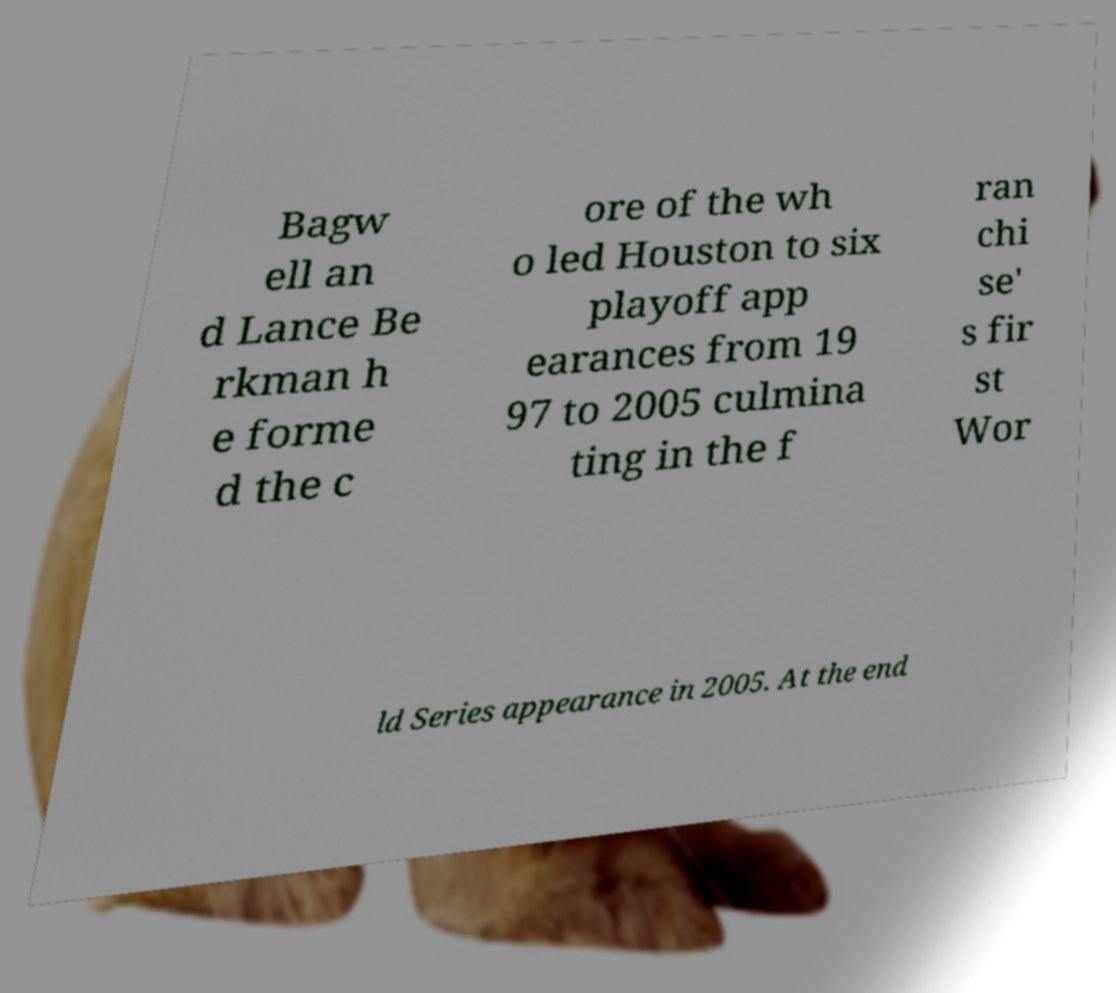Could you extract and type out the text from this image? Bagw ell an d Lance Be rkman h e forme d the c ore of the wh o led Houston to six playoff app earances from 19 97 to 2005 culmina ting in the f ran chi se' s fir st Wor ld Series appearance in 2005. At the end 